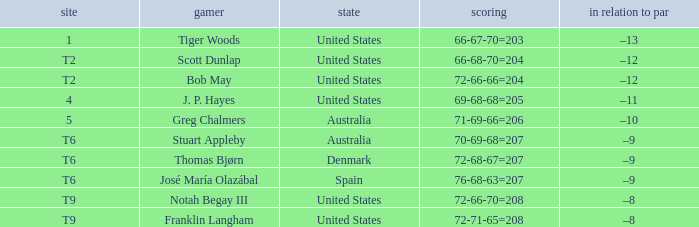What is the country of the player with a t6 place? Australia, Denmark, Spain. 